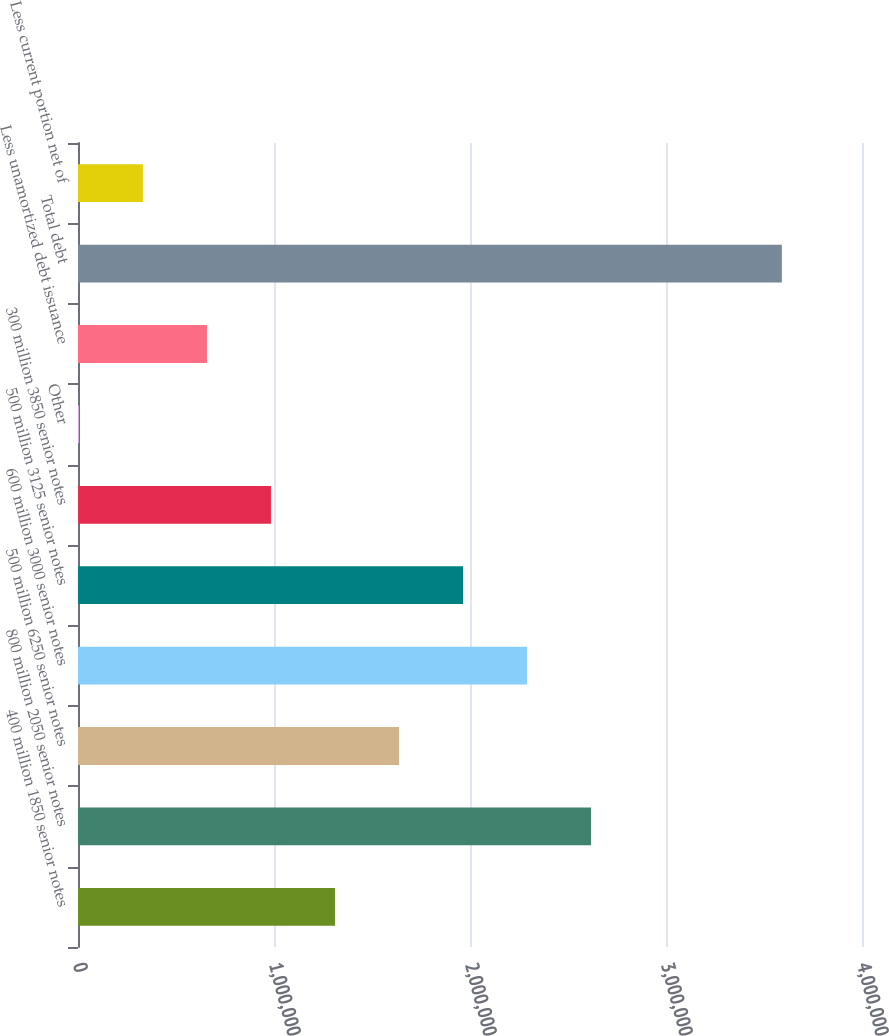Convert chart. <chart><loc_0><loc_0><loc_500><loc_500><bar_chart><fcel>400 million 1850 senior notes<fcel>800 million 2050 senior notes<fcel>500 million 6250 senior notes<fcel>600 million 3000 senior notes<fcel>500 million 3125 senior notes<fcel>300 million 3850 senior notes<fcel>Other<fcel>Less unamortized debt issuance<fcel>Total debt<fcel>Less current portion net of<nl><fcel>1.31115e+06<fcel>2.61786e+06<fcel>1.63783e+06<fcel>2.29119e+06<fcel>1.96451e+06<fcel>984471<fcel>4435<fcel>657792<fcel>3.5911e+06<fcel>331114<nl></chart> 